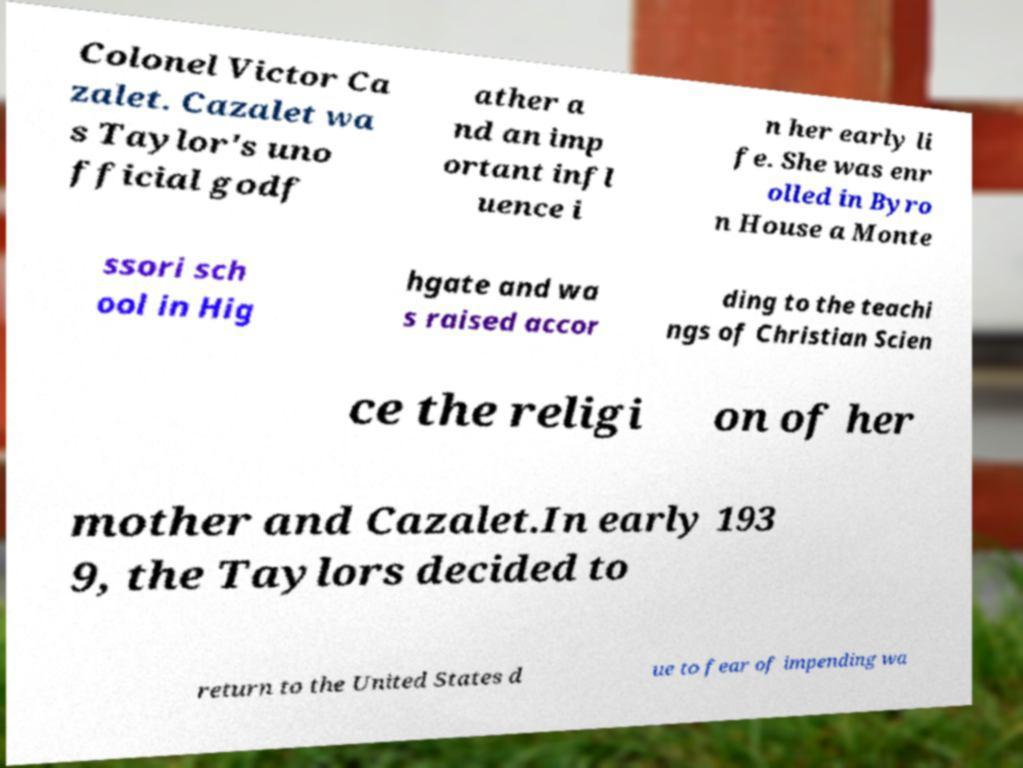For documentation purposes, I need the text within this image transcribed. Could you provide that? Colonel Victor Ca zalet. Cazalet wa s Taylor's uno fficial godf ather a nd an imp ortant infl uence i n her early li fe. She was enr olled in Byro n House a Monte ssori sch ool in Hig hgate and wa s raised accor ding to the teachi ngs of Christian Scien ce the religi on of her mother and Cazalet.In early 193 9, the Taylors decided to return to the United States d ue to fear of impending wa 